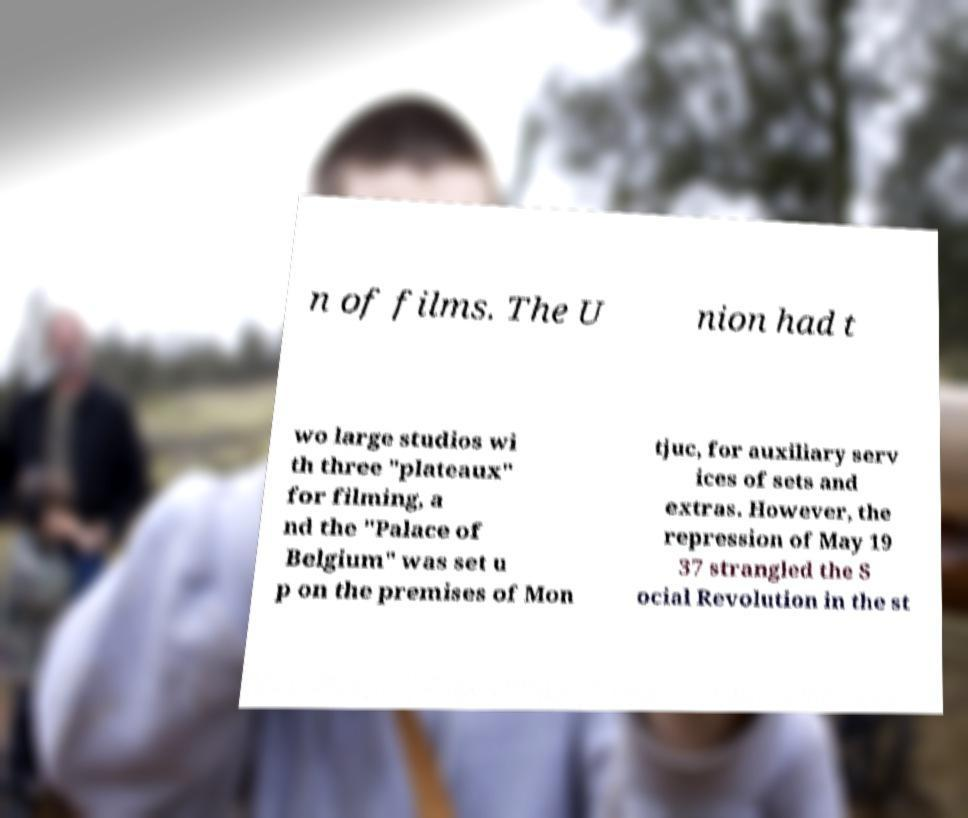Can you read and provide the text displayed in the image?This photo seems to have some interesting text. Can you extract and type it out for me? n of films. The U nion had t wo large studios wi th three "plateaux" for filming, a nd the "Palace of Belgium" was set u p on the premises of Mon tjuc, for auxiliary serv ices of sets and extras. However, the repression of May 19 37 strangled the S ocial Revolution in the st 